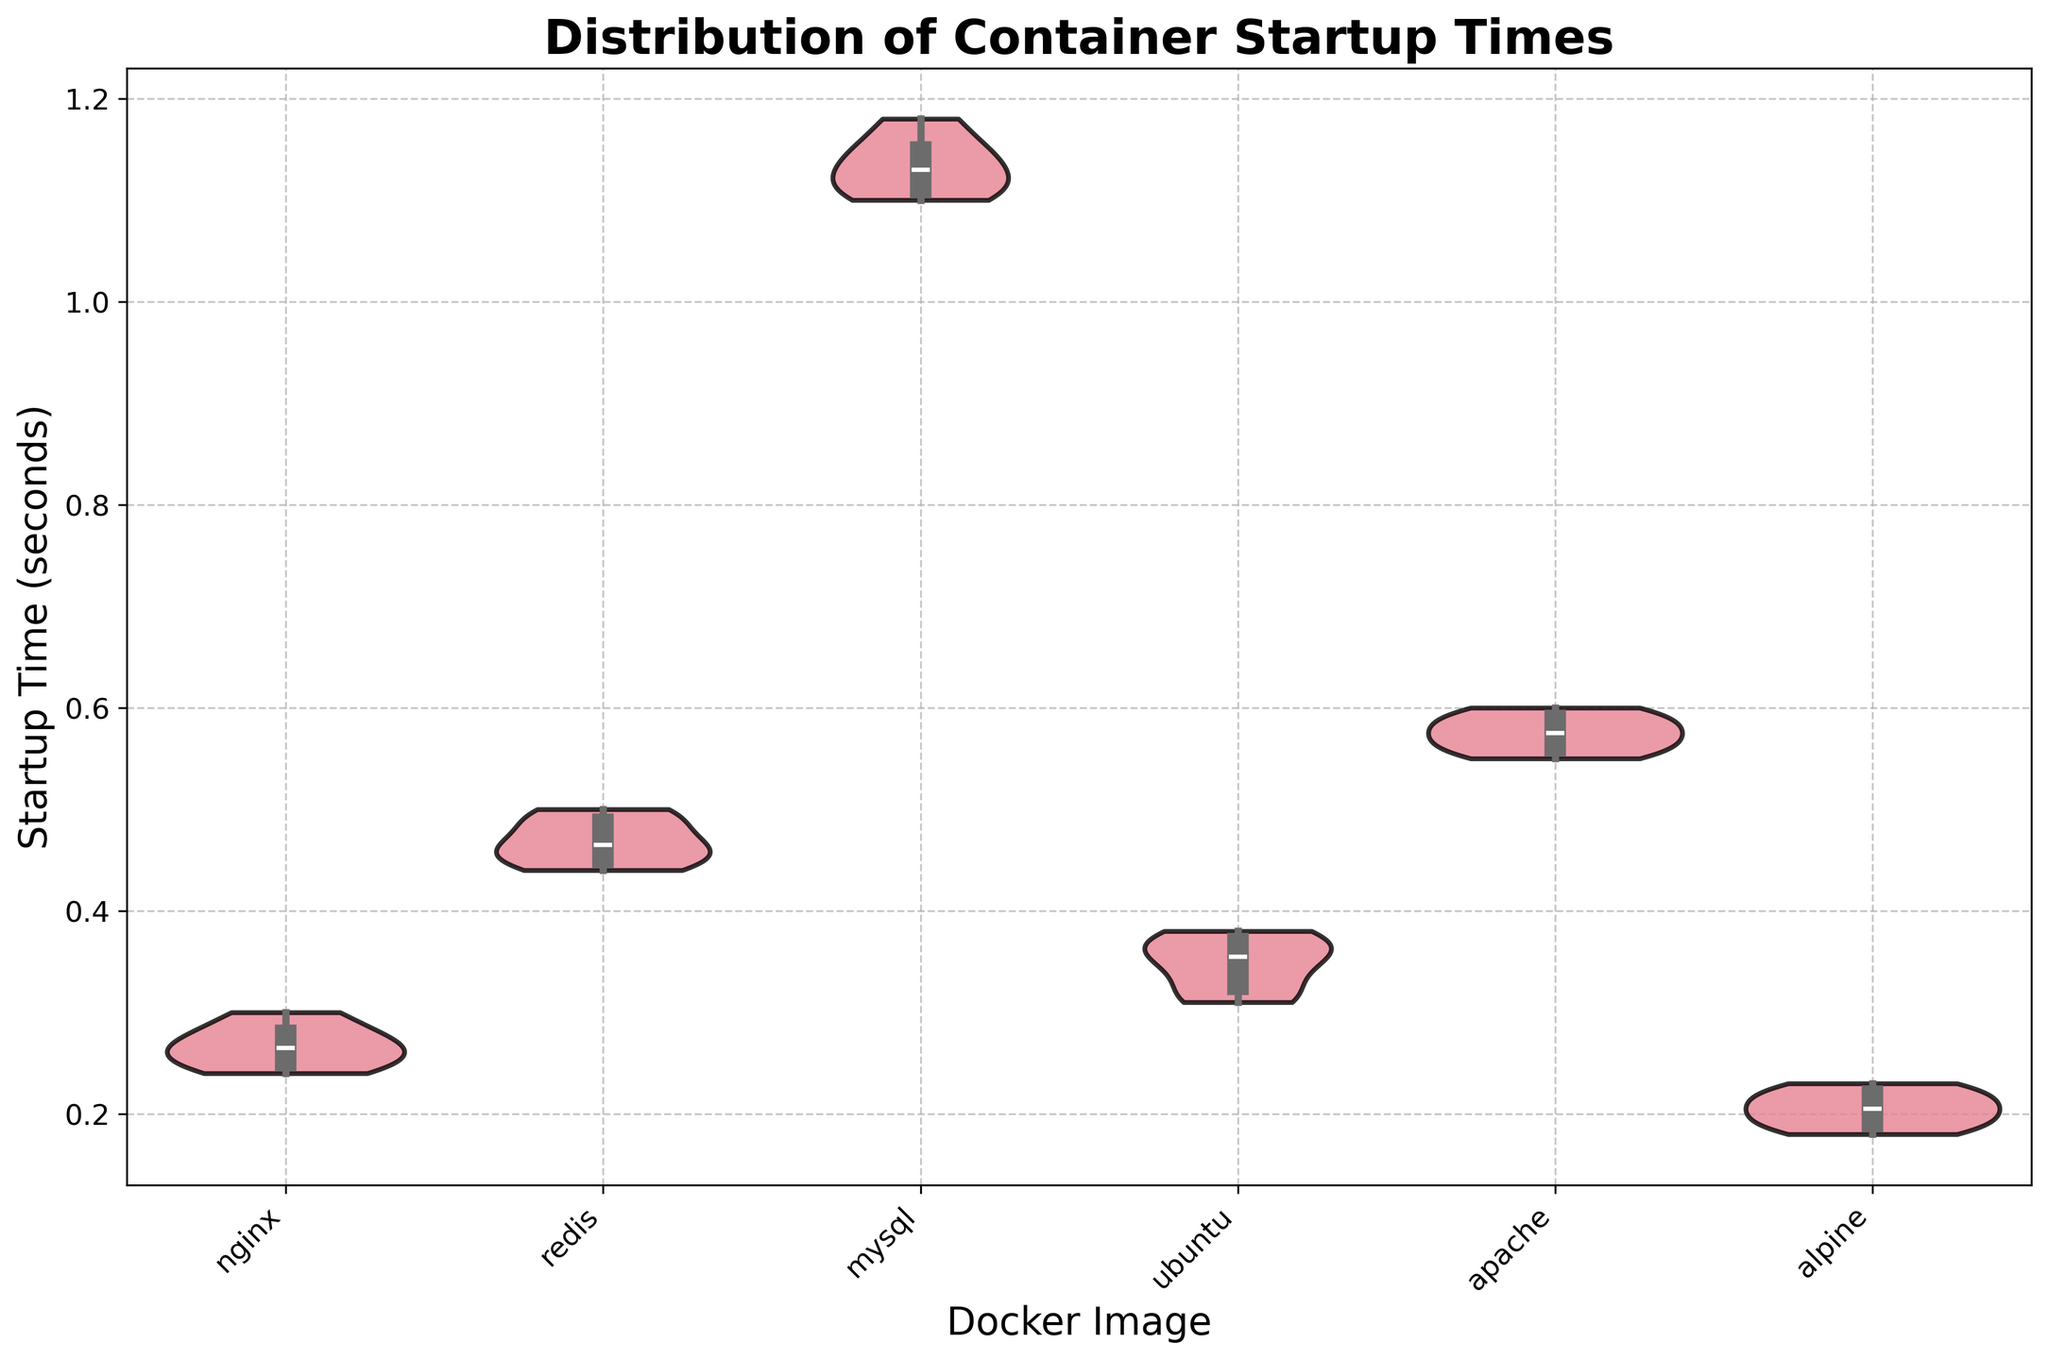What is the range of startup times for the 'nginx' Docker image? Look at the 'nginx' area of the violin plot. The lower and upper bounds of the violin show the range of startup times for 'nginx,' which is between 0.24 and 0.30 seconds.
Answer: 0.24 to 0.30 seconds What's the title of the plot? The title is the text located at the top center of the plot. It is shown in bold and large font.
Answer: Distribution of Container Startup Times Which Docker image has the smallest range of startup times? Compare the widths of the violins for all Docker images. The narrowest range indicates the smallest range. 'alpine' appears to have the smallest range.
Answer: alpine What's the median startup time for the 'mysql' Docker image? Locate the 'mysql' violin plot and note the position of the white dot within the violin. The white dot represents the median. It falls around 1.12 seconds.
Answer: 1.12 seconds How do the startup times of 'redis' compare to those of 'nginx'? Compare the violin shapes and ranges for 'redis' and 'nginx'. 'redis' has startup times between 0.44 and 0.50 seconds, which are generally higher than 'nginx' (0.24 to 0.30 seconds).
Answer: 'redis' startup times are higher Which Docker image has the highest median startup time? Look for the highest white dot across all violin plots. The white dot for 'mysql' appears higher than the others.
Answer: mysql What sort of summary statistics are shown inside the violins? The inner portion of the violins displays summary statistics such as the median (white dot) and the interquartile range (black box). These help understand central tendency and spread.
Answer: Median and interquartile range Which Docker image shows the most variation in startup times? Identify the violin with the largest width or spread. 'mysql' shows the most variation as its violin is the widest.
Answer: mysql 